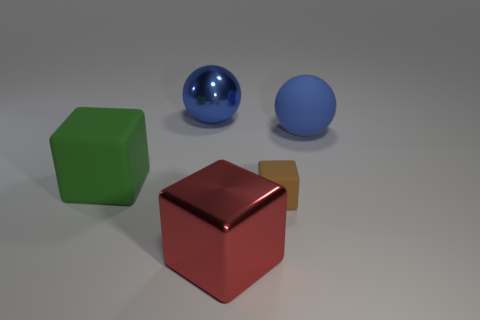Subtract all large green matte cubes. How many cubes are left? 2 Subtract all purple cubes. Subtract all yellow spheres. How many cubes are left? 3 Add 2 big red blocks. How many objects exist? 7 Subtract all blocks. How many objects are left? 2 Subtract all large red shiny blocks. Subtract all green cubes. How many objects are left? 3 Add 5 matte things. How many matte things are left? 8 Add 3 tiny yellow matte objects. How many tiny yellow matte objects exist? 3 Subtract 2 blue spheres. How many objects are left? 3 